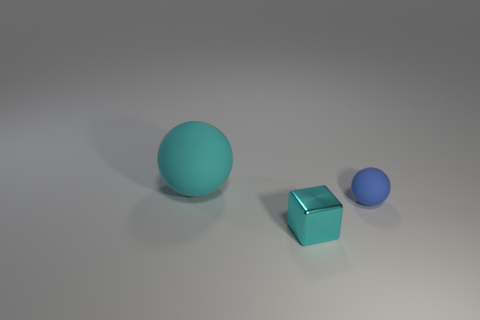Add 2 yellow spheres. How many objects exist? 5 Subtract all blue balls. How many balls are left? 1 Subtract all brown blocks. Subtract all blue cylinders. How many blocks are left? 1 Subtract all cyan cylinders. How many cyan balls are left? 1 Subtract all cubes. Subtract all tiny blue things. How many objects are left? 1 Add 3 matte spheres. How many matte spheres are left? 5 Add 1 small metal cylinders. How many small metal cylinders exist? 1 Subtract 0 purple cylinders. How many objects are left? 3 Subtract all blocks. How many objects are left? 2 